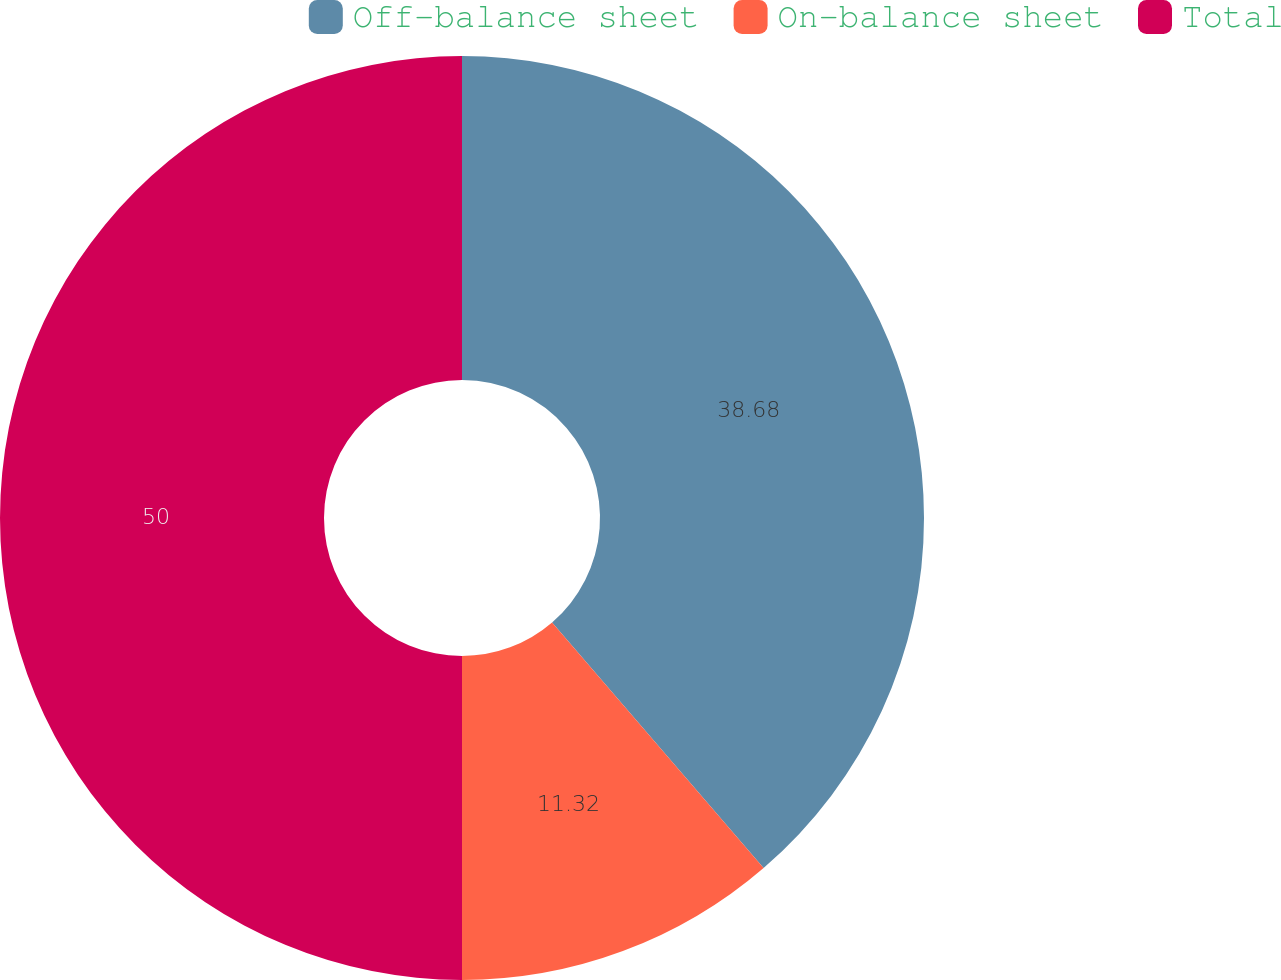Convert chart to OTSL. <chart><loc_0><loc_0><loc_500><loc_500><pie_chart><fcel>Off-balance sheet<fcel>On-balance sheet<fcel>Total<nl><fcel>38.68%<fcel>11.32%<fcel>50.0%<nl></chart> 